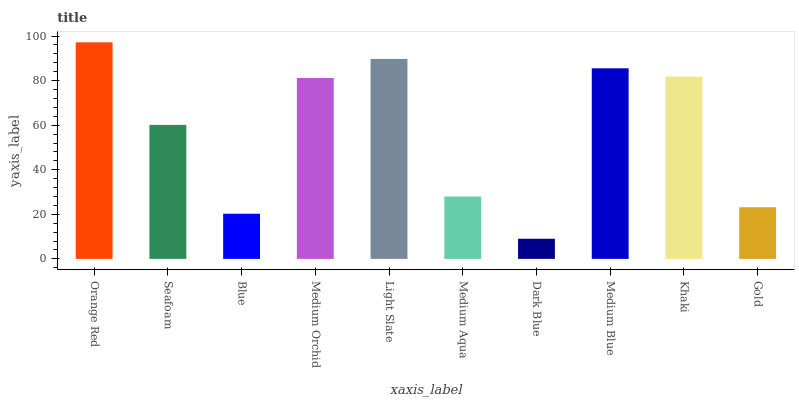Is Seafoam the minimum?
Answer yes or no. No. Is Seafoam the maximum?
Answer yes or no. No. Is Orange Red greater than Seafoam?
Answer yes or no. Yes. Is Seafoam less than Orange Red?
Answer yes or no. Yes. Is Seafoam greater than Orange Red?
Answer yes or no. No. Is Orange Red less than Seafoam?
Answer yes or no. No. Is Medium Orchid the high median?
Answer yes or no. Yes. Is Seafoam the low median?
Answer yes or no. Yes. Is Dark Blue the high median?
Answer yes or no. No. Is Light Slate the low median?
Answer yes or no. No. 